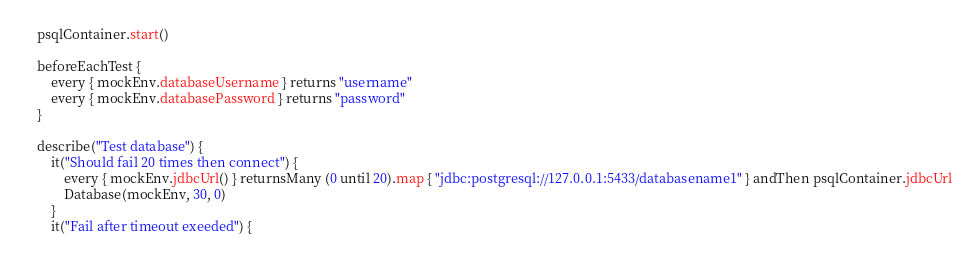<code> <loc_0><loc_0><loc_500><loc_500><_Kotlin_>    psqlContainer.start()

    beforeEachTest {
        every { mockEnv.databaseUsername } returns "username"
        every { mockEnv.databasePassword } returns "password"
    }

    describe("Test database") {
        it("Should fail 20 times then connect") {
            every { mockEnv.jdbcUrl() } returnsMany (0 until 20).map { "jdbc:postgresql://127.0.0.1:5433/databasename1" } andThen psqlContainer.jdbcUrl
            Database(mockEnv, 30, 0)
        }
        it("Fail after timeout exeeded") {</code> 